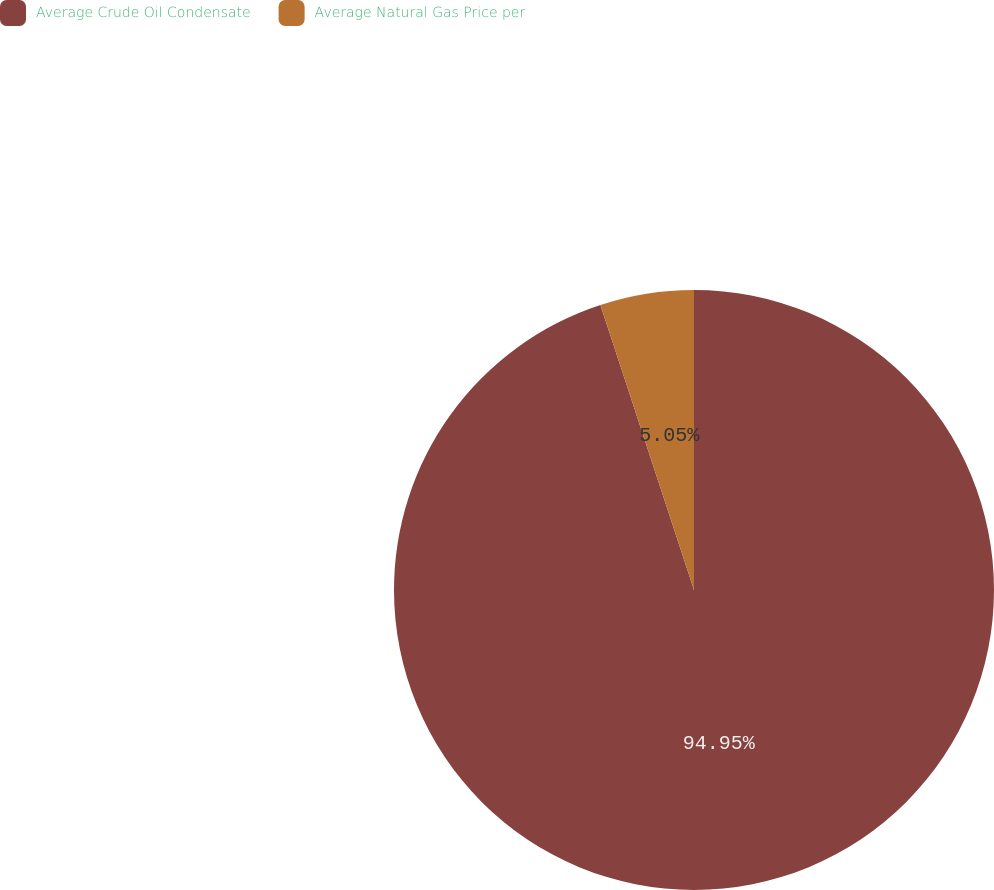Convert chart to OTSL. <chart><loc_0><loc_0><loc_500><loc_500><pie_chart><fcel>Average Crude Oil Condensate<fcel>Average Natural Gas Price per<nl><fcel>94.95%<fcel>5.05%<nl></chart> 